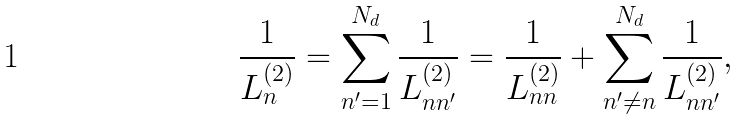<formula> <loc_0><loc_0><loc_500><loc_500>\frac { 1 } { L ^ { ( 2 ) } _ { n } } = \sum _ { n ^ { \prime } = 1 } ^ { N _ { d } } \frac { 1 } { L ^ { ( 2 ) } _ { n n ^ { \prime } } } = \frac { 1 } { L ^ { ( 2 ) } _ { n n } } + \sum _ { n ^ { \prime } \neq n } ^ { N _ { d } } \frac { 1 } { L ^ { ( 2 ) } _ { n n ^ { \prime } } } ,</formula> 